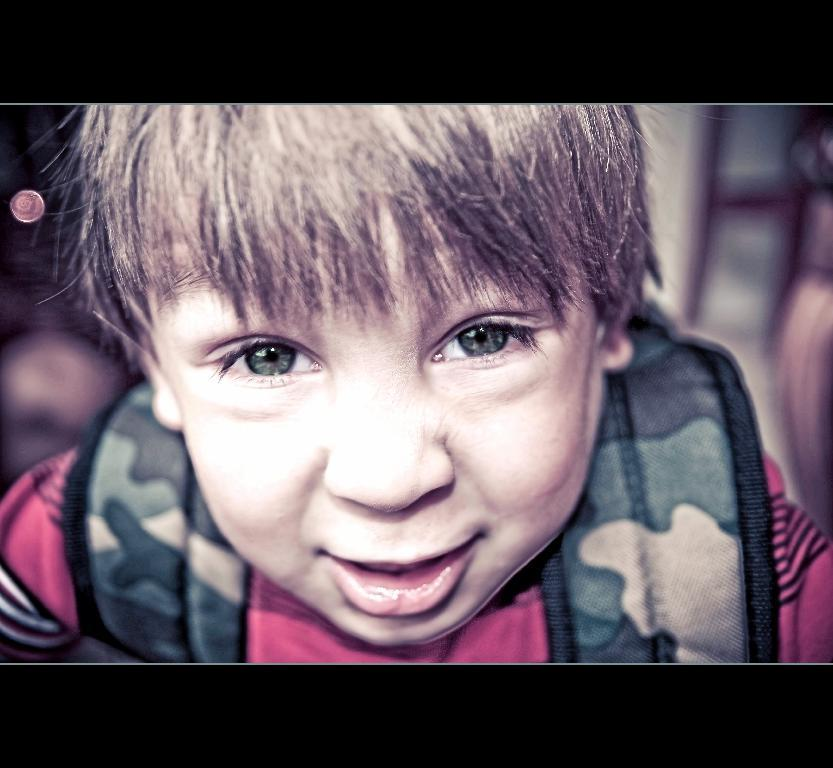What is the main subject of the image? There is a boy in the image. Can you describe the boy's appearance or actions in the image? Unfortunately, the provided facts do not give any information about the boy's appearance or actions. Is the boy alone in the image, or are there other people or objects present? The provided facts do not mention any other people or objects in the image. What is the learning rate of the animal in the image? There is no animal present in the image, and therefore no learning rate can be determined. 